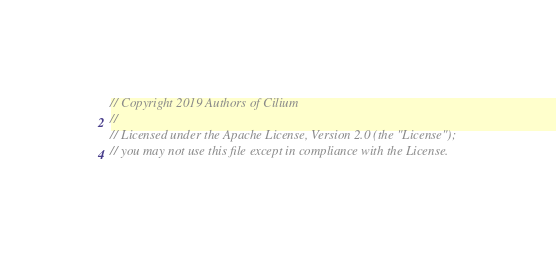Convert code to text. <code><loc_0><loc_0><loc_500><loc_500><_Go_>// Copyright 2019 Authors of Cilium
//
// Licensed under the Apache License, Version 2.0 (the "License");
// you may not use this file except in compliance with the License.</code> 